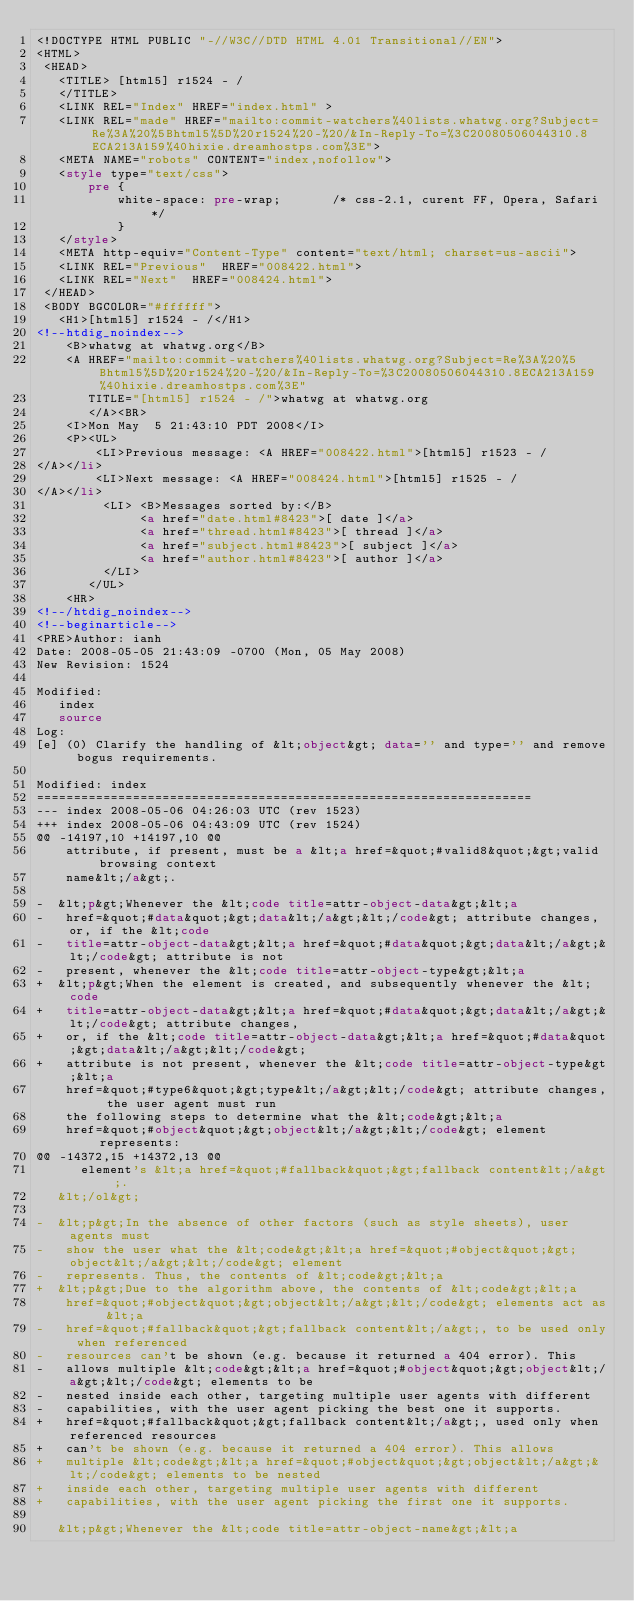<code> <loc_0><loc_0><loc_500><loc_500><_HTML_><!DOCTYPE HTML PUBLIC "-//W3C//DTD HTML 4.01 Transitional//EN">
<HTML>
 <HEAD>
   <TITLE> [html5] r1524 - /
   </TITLE>
   <LINK REL="Index" HREF="index.html" >
   <LINK REL="made" HREF="mailto:commit-watchers%40lists.whatwg.org?Subject=Re%3A%20%5Bhtml5%5D%20r1524%20-%20/&In-Reply-To=%3C20080506044310.8ECA213A159%40hixie.dreamhostps.com%3E">
   <META NAME="robots" CONTENT="index,nofollow">
   <style type="text/css">
       pre {
           white-space: pre-wrap;       /* css-2.1, curent FF, Opera, Safari */
           }
   </style>
   <META http-equiv="Content-Type" content="text/html; charset=us-ascii">
   <LINK REL="Previous"  HREF="008422.html">
   <LINK REL="Next"  HREF="008424.html">
 </HEAD>
 <BODY BGCOLOR="#ffffff">
   <H1>[html5] r1524 - /</H1>
<!--htdig_noindex-->
    <B>whatwg at whatwg.org</B> 
    <A HREF="mailto:commit-watchers%40lists.whatwg.org?Subject=Re%3A%20%5Bhtml5%5D%20r1524%20-%20/&In-Reply-To=%3C20080506044310.8ECA213A159%40hixie.dreamhostps.com%3E"
       TITLE="[html5] r1524 - /">whatwg at whatwg.org
       </A><BR>
    <I>Mon May  5 21:43:10 PDT 2008</I>
    <P><UL>
        <LI>Previous message: <A HREF="008422.html">[html5] r1523 - /
</A></li>
        <LI>Next message: <A HREF="008424.html">[html5] r1525 - /
</A></li>
         <LI> <B>Messages sorted by:</B> 
              <a href="date.html#8423">[ date ]</a>
              <a href="thread.html#8423">[ thread ]</a>
              <a href="subject.html#8423">[ subject ]</a>
              <a href="author.html#8423">[ author ]</a>
         </LI>
       </UL>
    <HR>  
<!--/htdig_noindex-->
<!--beginarticle-->
<PRE>Author: ianh
Date: 2008-05-05 21:43:09 -0700 (Mon, 05 May 2008)
New Revision: 1524

Modified:
   index
   source
Log:
[e] (0) Clarify the handling of &lt;object&gt; data='' and type='' and remove bogus requirements.

Modified: index
===================================================================
--- index	2008-05-06 04:26:03 UTC (rev 1523)
+++ index	2008-05-06 04:43:09 UTC (rev 1524)
@@ -14197,10 +14197,10 @@
    attribute, if present, must be a &lt;a href=&quot;#valid8&quot;&gt;valid browsing context
    name&lt;/a&gt;.
 
-  &lt;p&gt;Whenever the &lt;code title=attr-object-data&gt;&lt;a
-   href=&quot;#data&quot;&gt;data&lt;/a&gt;&lt;/code&gt; attribute changes, or, if the &lt;code
-   title=attr-object-data&gt;&lt;a href=&quot;#data&quot;&gt;data&lt;/a&gt;&lt;/code&gt; attribute is not
-   present, whenever the &lt;code title=attr-object-type&gt;&lt;a
+  &lt;p&gt;When the element is created, and subsequently whenever the &lt;code
+   title=attr-object-data&gt;&lt;a href=&quot;#data&quot;&gt;data&lt;/a&gt;&lt;/code&gt; attribute changes,
+   or, if the &lt;code title=attr-object-data&gt;&lt;a href=&quot;#data&quot;&gt;data&lt;/a&gt;&lt;/code&gt;
+   attribute is not present, whenever the &lt;code title=attr-object-type&gt;&lt;a
    href=&quot;#type6&quot;&gt;type&lt;/a&gt;&lt;/code&gt; attribute changes, the user agent must run
    the following steps to determine what the &lt;code&gt;&lt;a
    href=&quot;#object&quot;&gt;object&lt;/a&gt;&lt;/code&gt; element represents:
@@ -14372,15 +14372,13 @@
      element's &lt;a href=&quot;#fallback&quot;&gt;fallback content&lt;/a&gt;.
   &lt;/ol&gt;
 
-  &lt;p&gt;In the absence of other factors (such as style sheets), user agents must
-   show the user what the &lt;code&gt;&lt;a href=&quot;#object&quot;&gt;object&lt;/a&gt;&lt;/code&gt; element
-   represents. Thus, the contents of &lt;code&gt;&lt;a
+  &lt;p&gt;Due to the algorithm above, the contents of &lt;code&gt;&lt;a
    href=&quot;#object&quot;&gt;object&lt;/a&gt;&lt;/code&gt; elements act as &lt;a
-   href=&quot;#fallback&quot;&gt;fallback content&lt;/a&gt;, to be used only when referenced
-   resources can't be shown (e.g. because it returned a 404 error). This
-   allows multiple &lt;code&gt;&lt;a href=&quot;#object&quot;&gt;object&lt;/a&gt;&lt;/code&gt; elements to be
-   nested inside each other, targeting multiple user agents with different
-   capabilities, with the user agent picking the best one it supports.
+   href=&quot;#fallback&quot;&gt;fallback content&lt;/a&gt;, used only when referenced resources
+   can't be shown (e.g. because it returned a 404 error). This allows
+   multiple &lt;code&gt;&lt;a href=&quot;#object&quot;&gt;object&lt;/a&gt;&lt;/code&gt; elements to be nested
+   inside each other, targeting multiple user agents with different
+   capabilities, with the user agent picking the first one it supports.
 
   &lt;p&gt;Whenever the &lt;code title=attr-object-name&gt;&lt;a</code> 